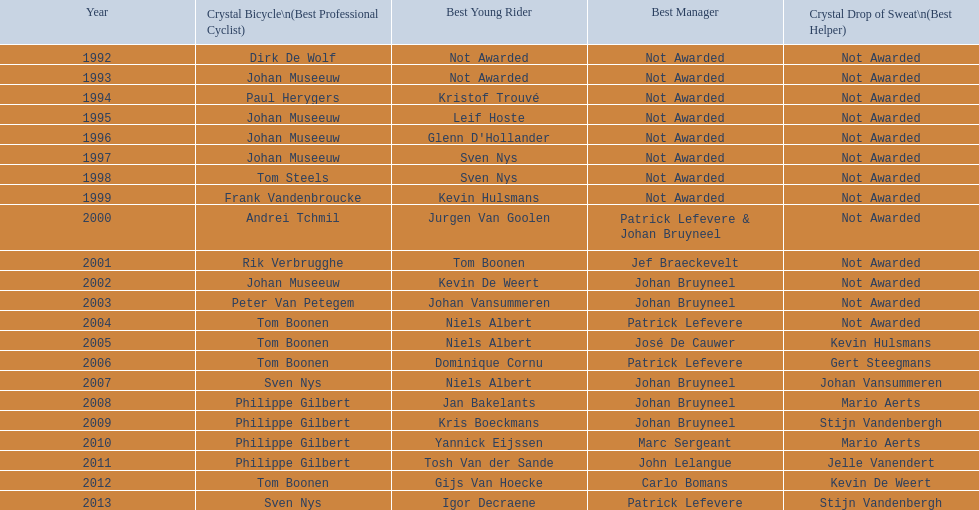On average, in how many instances was johan museeuw a star? 5. Could you help me parse every detail presented in this table? {'header': ['Year', 'Crystal Bicycle\\n(Best Professional Cyclist)', 'Best Young Rider', 'Best Manager', 'Crystal Drop of Sweat\\n(Best Helper)'], 'rows': [['1992', 'Dirk De Wolf', 'Not Awarded', 'Not Awarded', 'Not Awarded'], ['1993', 'Johan Museeuw', 'Not Awarded', 'Not Awarded', 'Not Awarded'], ['1994', 'Paul Herygers', 'Kristof Trouvé', 'Not Awarded', 'Not Awarded'], ['1995', 'Johan Museeuw', 'Leif Hoste', 'Not Awarded', 'Not Awarded'], ['1996', 'Johan Museeuw', "Glenn D'Hollander", 'Not Awarded', 'Not Awarded'], ['1997', 'Johan Museeuw', 'Sven Nys', 'Not Awarded', 'Not Awarded'], ['1998', 'Tom Steels', 'Sven Nys', 'Not Awarded', 'Not Awarded'], ['1999', 'Frank Vandenbroucke', 'Kevin Hulsmans', 'Not Awarded', 'Not Awarded'], ['2000', 'Andrei Tchmil', 'Jurgen Van Goolen', 'Patrick Lefevere & Johan Bruyneel', 'Not Awarded'], ['2001', 'Rik Verbrugghe', 'Tom Boonen', 'Jef Braeckevelt', 'Not Awarded'], ['2002', 'Johan Museeuw', 'Kevin De Weert', 'Johan Bruyneel', 'Not Awarded'], ['2003', 'Peter Van Petegem', 'Johan Vansummeren', 'Johan Bruyneel', 'Not Awarded'], ['2004', 'Tom Boonen', 'Niels Albert', 'Patrick Lefevere', 'Not Awarded'], ['2005', 'Tom Boonen', 'Niels Albert', 'José De Cauwer', 'Kevin Hulsmans'], ['2006', 'Tom Boonen', 'Dominique Cornu', 'Patrick Lefevere', 'Gert Steegmans'], ['2007', 'Sven Nys', 'Niels Albert', 'Johan Bruyneel', 'Johan Vansummeren'], ['2008', 'Philippe Gilbert', 'Jan Bakelants', 'Johan Bruyneel', 'Mario Aerts'], ['2009', 'Philippe Gilbert', 'Kris Boeckmans', 'Johan Bruyneel', 'Stijn Vandenbergh'], ['2010', 'Philippe Gilbert', 'Yannick Eijssen', 'Marc Sergeant', 'Mario Aerts'], ['2011', 'Philippe Gilbert', 'Tosh Van der Sande', 'John Lelangue', 'Jelle Vanendert'], ['2012', 'Tom Boonen', 'Gijs Van Hoecke', 'Carlo Bomans', 'Kevin De Weert'], ['2013', 'Sven Nys', 'Igor Decraene', 'Patrick Lefevere', 'Stijn Vandenbergh']]} 